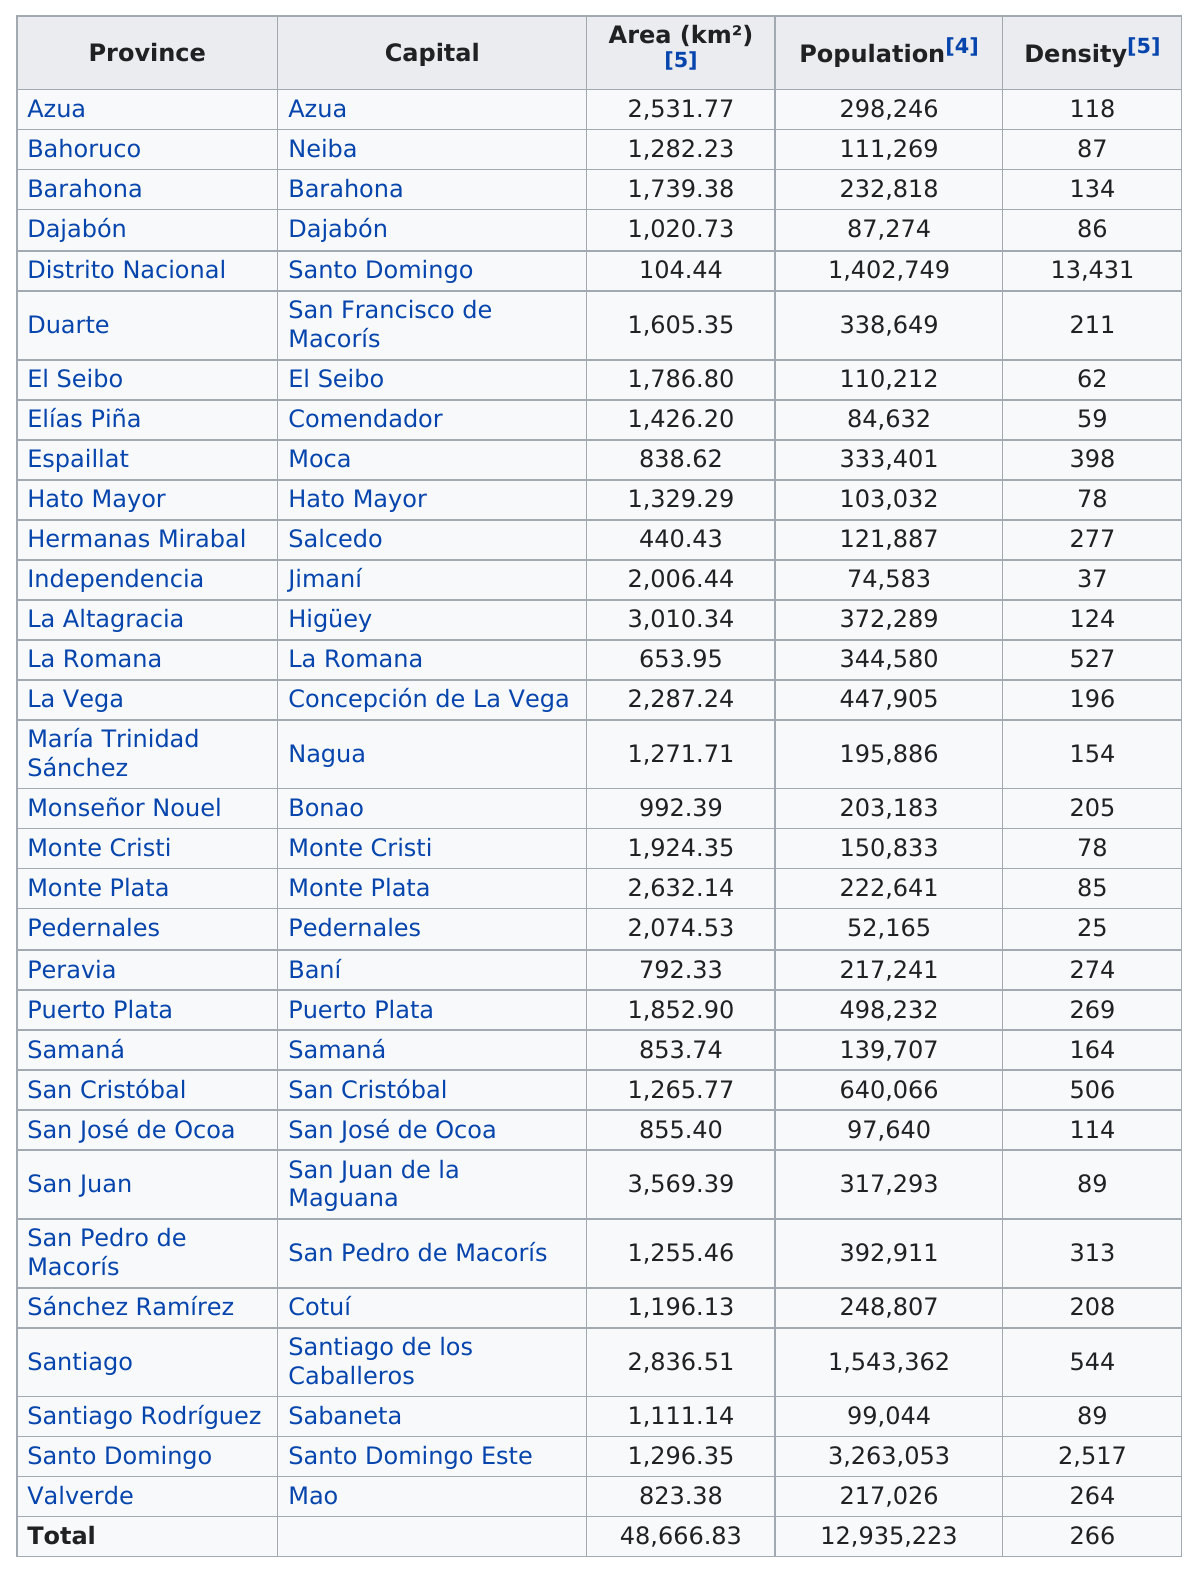Give some essential details in this illustration. San Juan is the province with the largest area in the country. The province in the Dominican Republic with the largest population is Santo Domingo. There are 12 provinces with populations higher than 300,000. The population of San Juan is 68,486, while the population of Sanchez Ramirez is significantly lower at 32,935. Pedernales is the only province in the Dominican Republic with a population density under 30 people per square kilometer. 